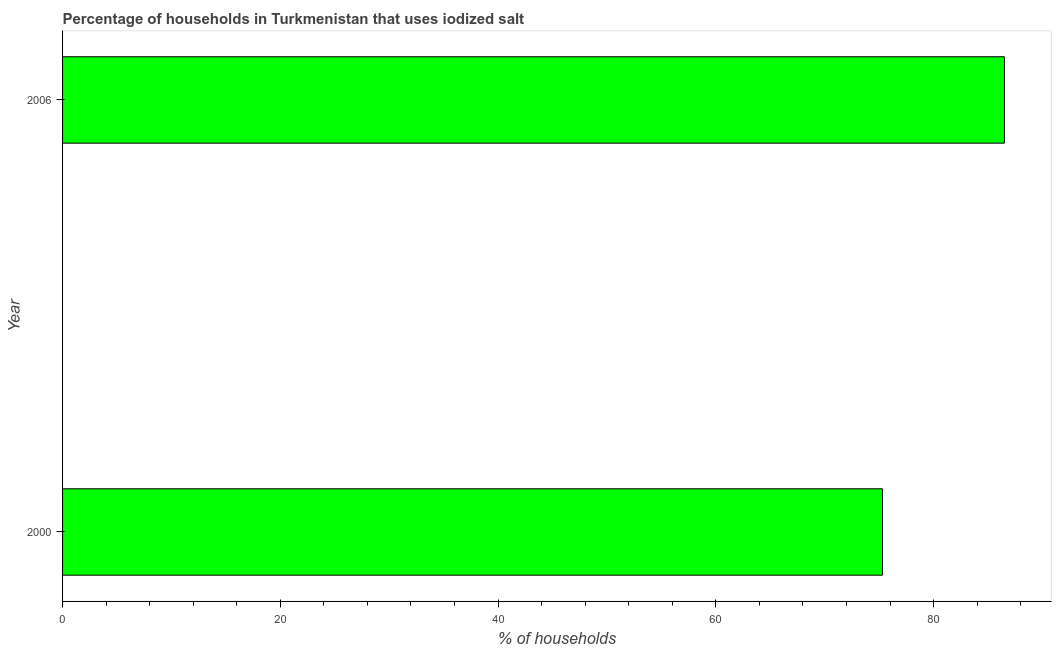Does the graph contain grids?
Your answer should be very brief. No. What is the title of the graph?
Offer a terse response. Percentage of households in Turkmenistan that uses iodized salt. What is the label or title of the X-axis?
Offer a very short reply. % of households. What is the percentage of households where iodized salt is consumed in 2000?
Offer a very short reply. 75.3. Across all years, what is the maximum percentage of households where iodized salt is consumed?
Provide a succinct answer. 86.5. Across all years, what is the minimum percentage of households where iodized salt is consumed?
Give a very brief answer. 75.3. In which year was the percentage of households where iodized salt is consumed minimum?
Provide a succinct answer. 2000. What is the sum of the percentage of households where iodized salt is consumed?
Offer a very short reply. 161.8. What is the difference between the percentage of households where iodized salt is consumed in 2000 and 2006?
Make the answer very short. -11.2. What is the average percentage of households where iodized salt is consumed per year?
Ensure brevity in your answer.  80.9. What is the median percentage of households where iodized salt is consumed?
Provide a succinct answer. 80.9. What is the ratio of the percentage of households where iodized salt is consumed in 2000 to that in 2006?
Ensure brevity in your answer.  0.87. In how many years, is the percentage of households where iodized salt is consumed greater than the average percentage of households where iodized salt is consumed taken over all years?
Offer a very short reply. 1. How many bars are there?
Provide a short and direct response. 2. What is the % of households of 2000?
Give a very brief answer. 75.3. What is the % of households of 2006?
Make the answer very short. 86.5. What is the difference between the % of households in 2000 and 2006?
Make the answer very short. -11.2. What is the ratio of the % of households in 2000 to that in 2006?
Provide a short and direct response. 0.87. 